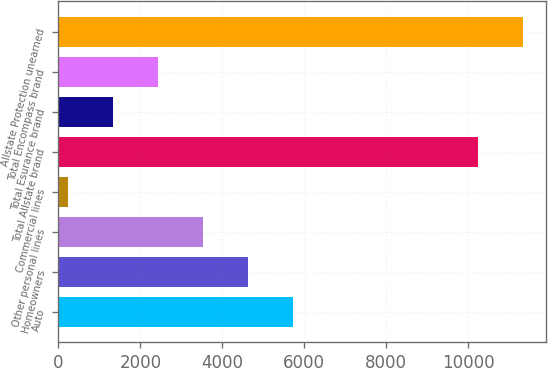Convert chart. <chart><loc_0><loc_0><loc_500><loc_500><bar_chart><fcel>Auto<fcel>Homeowners<fcel>Other personal lines<fcel>Commercial lines<fcel>Total Allstate brand<fcel>Total Esurance brand<fcel>Total Encompass brand<fcel>Allstate Protection unearned<nl><fcel>5729.5<fcel>4632.8<fcel>3536.1<fcel>246<fcel>10230<fcel>1342.7<fcel>2439.4<fcel>11326.7<nl></chart> 